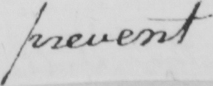Transcribe the text shown in this historical manuscript line. prevent 